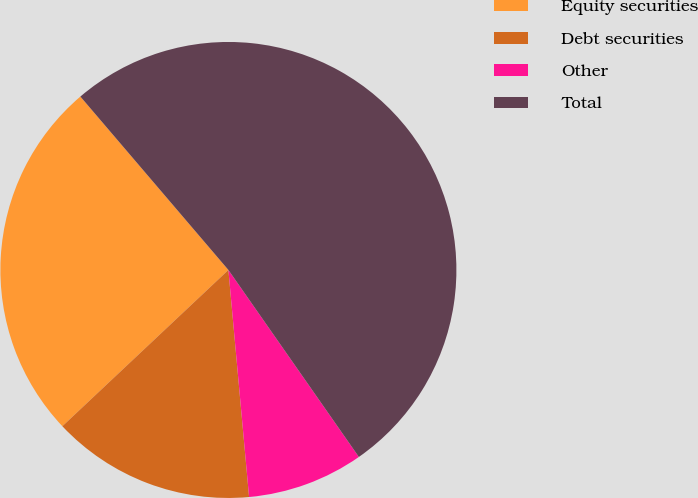Convert chart. <chart><loc_0><loc_0><loc_500><loc_500><pie_chart><fcel>Equity securities<fcel>Debt securities<fcel>Other<fcel>Total<nl><fcel>25.77%<fcel>14.43%<fcel>8.25%<fcel>51.55%<nl></chart> 